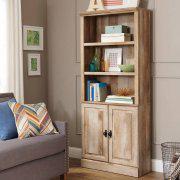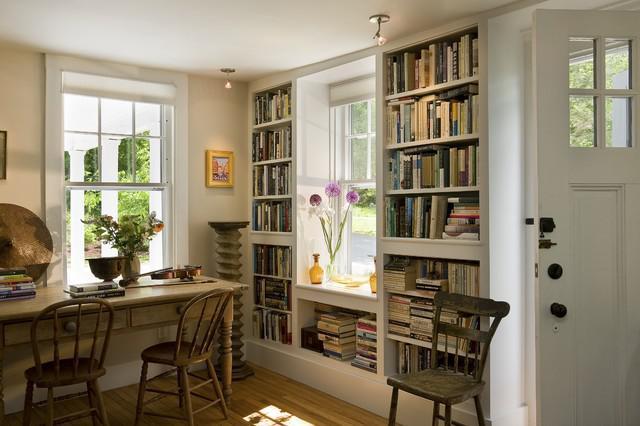The first image is the image on the left, the second image is the image on the right. Considering the images on both sides, is "a bookshelf is behind a small white table" valid? Answer yes or no. No. The first image is the image on the left, the second image is the image on the right. Considering the images on both sides, is "The bookshelves in both pictures are facing the left side of the picture." valid? Answer yes or no. Yes. 